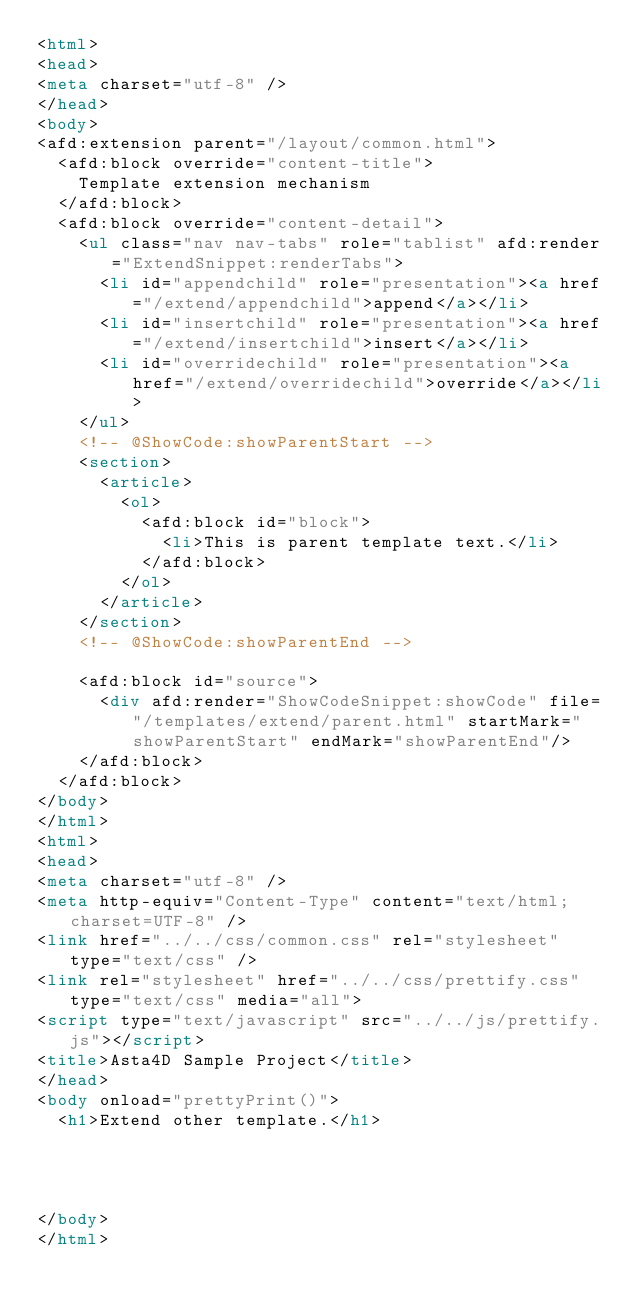<code> <loc_0><loc_0><loc_500><loc_500><_HTML_><html>
<head>
<meta charset="utf-8" />
</head>
<body>
<afd:extension parent="/layout/common.html">
	<afd:block override="content-title">
		Template extension mechanism
	</afd:block>
	<afd:block override="content-detail">
		<ul class="nav nav-tabs" role="tablist" afd:render="ExtendSnippet:renderTabs">
			<li id="appendchild" role="presentation"><a href="/extend/appendchild">append</a></li>
			<li id="insertchild" role="presentation"><a href="/extend/insertchild">insert</a></li>
			<li id="overridechild" role="presentation"><a href="/extend/overridechild">override</a></li>
		</ul>
		<!-- @ShowCode:showParentStart -->
		<section>
			<article>
				<ol>
					<afd:block id="block">
						<li>This is parent template text.</li>
					</afd:block>
				</ol>
			</article>
		</section>
		<!-- @ShowCode:showParentEnd -->
	
		<afd:block id="source">
	 		<div afd:render="ShowCodeSnippet:showCode" file="/templates/extend/parent.html" startMark="showParentStart" endMark="showParentEnd"/>
		</afd:block>
	</afd:block>
</body>
</html>
<html>
<head>
<meta charset="utf-8" />
<meta http-equiv="Content-Type" content="text/html; charset=UTF-8" />
<link href="../../css/common.css" rel="stylesheet" type="text/css" />
<link rel="stylesheet" href="../../css/prettify.css" type="text/css" media="all">
<script type="text/javascript" src="../../js/prettify.js"></script>
<title>Asta4D Sample Project</title>
</head>
<body onload="prettyPrint()">
	<h1>Extend other template.</h1>




</body>
</html></code> 